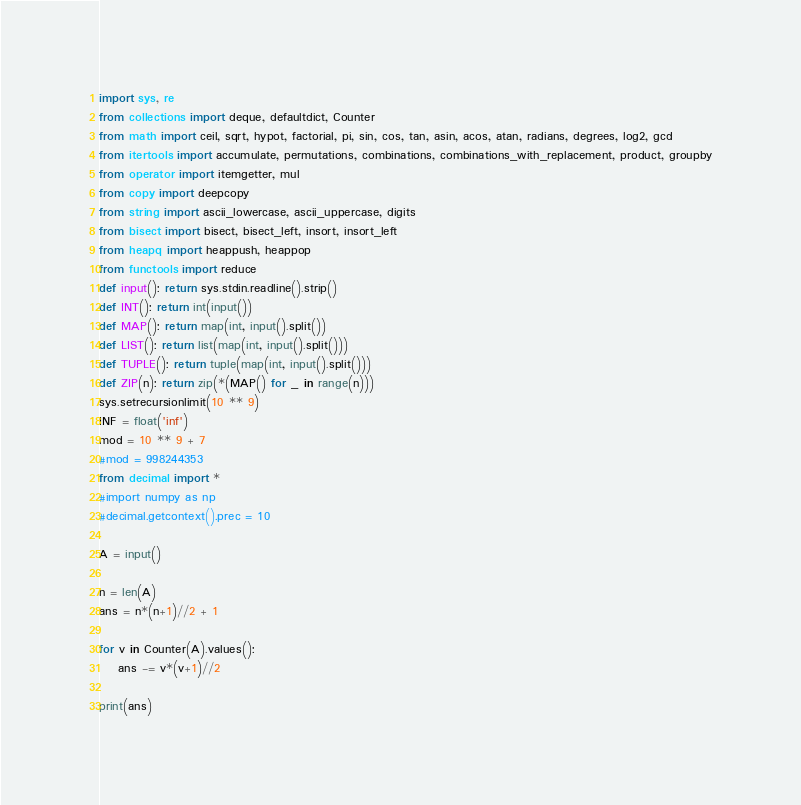Convert code to text. <code><loc_0><loc_0><loc_500><loc_500><_Python_>import sys, re
from collections import deque, defaultdict, Counter
from math import ceil, sqrt, hypot, factorial, pi, sin, cos, tan, asin, acos, atan, radians, degrees, log2, gcd
from itertools import accumulate, permutations, combinations, combinations_with_replacement, product, groupby
from operator import itemgetter, mul
from copy import deepcopy
from string import ascii_lowercase, ascii_uppercase, digits
from bisect import bisect, bisect_left, insort, insort_left
from heapq import heappush, heappop
from functools import reduce
def input(): return sys.stdin.readline().strip()
def INT(): return int(input())
def MAP(): return map(int, input().split())
def LIST(): return list(map(int, input().split()))
def TUPLE(): return tuple(map(int, input().split()))
def ZIP(n): return zip(*(MAP() for _ in range(n)))
sys.setrecursionlimit(10 ** 9)
INF = float('inf')
mod = 10 ** 9 + 7 
#mod = 998244353
from decimal import *
#import numpy as np
#decimal.getcontext().prec = 10

A = input()

n = len(A)
ans = n*(n+1)//2 + 1

for v in Counter(A).values():
	ans -= v*(v+1)//2

print(ans)</code> 